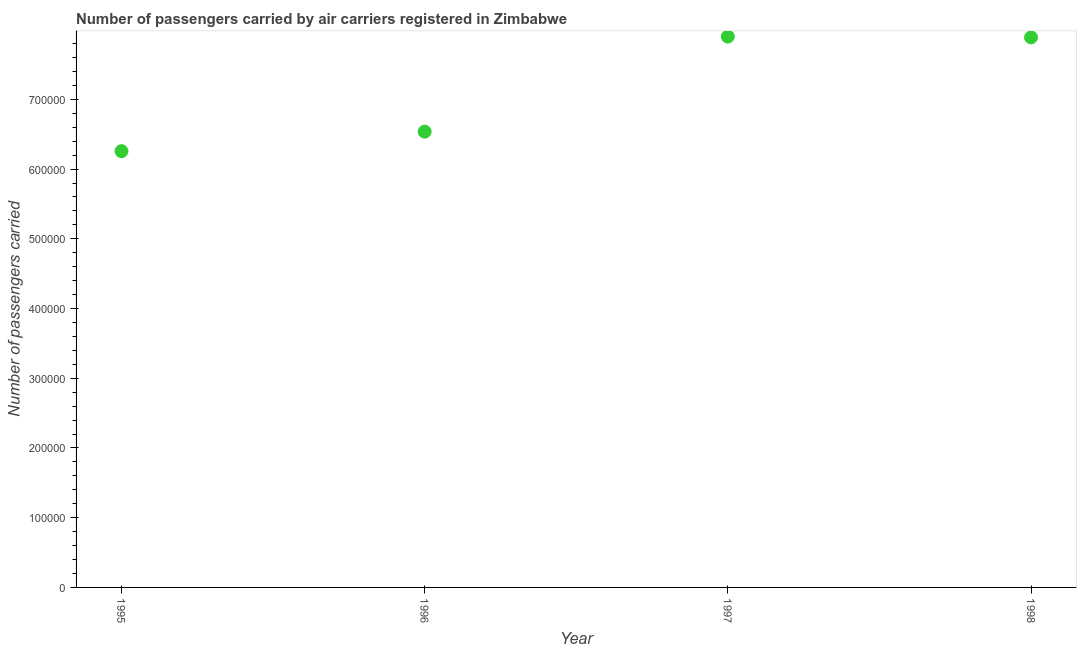What is the number of passengers carried in 1996?
Ensure brevity in your answer.  6.54e+05. Across all years, what is the maximum number of passengers carried?
Make the answer very short. 7.90e+05. Across all years, what is the minimum number of passengers carried?
Provide a short and direct response. 6.26e+05. In which year was the number of passengers carried minimum?
Offer a terse response. 1995. What is the sum of the number of passengers carried?
Offer a very short reply. 2.86e+06. What is the difference between the number of passengers carried in 1995 and 1996?
Make the answer very short. -2.80e+04. What is the average number of passengers carried per year?
Provide a succinct answer. 7.15e+05. What is the median number of passengers carried?
Offer a very short reply. 7.21e+05. In how many years, is the number of passengers carried greater than 660000 ?
Keep it short and to the point. 2. Do a majority of the years between 1996 and 1998 (inclusive) have number of passengers carried greater than 620000 ?
Keep it short and to the point. Yes. What is the ratio of the number of passengers carried in 1996 to that in 1997?
Ensure brevity in your answer.  0.83. Is the difference between the number of passengers carried in 1996 and 1997 greater than the difference between any two years?
Your response must be concise. No. What is the difference between the highest and the second highest number of passengers carried?
Your answer should be very brief. 1200. Is the sum of the number of passengers carried in 1995 and 1996 greater than the maximum number of passengers carried across all years?
Ensure brevity in your answer.  Yes. What is the difference between the highest and the lowest number of passengers carried?
Your answer should be very brief. 1.64e+05. In how many years, is the number of passengers carried greater than the average number of passengers carried taken over all years?
Make the answer very short. 2. Does the number of passengers carried monotonically increase over the years?
Offer a terse response. No. What is the difference between two consecutive major ticks on the Y-axis?
Your answer should be very brief. 1.00e+05. Are the values on the major ticks of Y-axis written in scientific E-notation?
Ensure brevity in your answer.  No. Does the graph contain any zero values?
Make the answer very short. No. What is the title of the graph?
Make the answer very short. Number of passengers carried by air carriers registered in Zimbabwe. What is the label or title of the Y-axis?
Your response must be concise. Number of passengers carried. What is the Number of passengers carried in 1995?
Your answer should be compact. 6.26e+05. What is the Number of passengers carried in 1996?
Provide a succinct answer. 6.54e+05. What is the Number of passengers carried in 1997?
Your answer should be compact. 7.90e+05. What is the Number of passengers carried in 1998?
Make the answer very short. 7.89e+05. What is the difference between the Number of passengers carried in 1995 and 1996?
Offer a terse response. -2.80e+04. What is the difference between the Number of passengers carried in 1995 and 1997?
Offer a terse response. -1.64e+05. What is the difference between the Number of passengers carried in 1995 and 1998?
Offer a very short reply. -1.63e+05. What is the difference between the Number of passengers carried in 1996 and 1997?
Your answer should be compact. -1.36e+05. What is the difference between the Number of passengers carried in 1996 and 1998?
Make the answer very short. -1.35e+05. What is the difference between the Number of passengers carried in 1997 and 1998?
Provide a short and direct response. 1200. What is the ratio of the Number of passengers carried in 1995 to that in 1996?
Your answer should be compact. 0.96. What is the ratio of the Number of passengers carried in 1995 to that in 1997?
Your answer should be compact. 0.79. What is the ratio of the Number of passengers carried in 1995 to that in 1998?
Your response must be concise. 0.79. What is the ratio of the Number of passengers carried in 1996 to that in 1997?
Give a very brief answer. 0.83. What is the ratio of the Number of passengers carried in 1996 to that in 1998?
Your answer should be very brief. 0.83. 